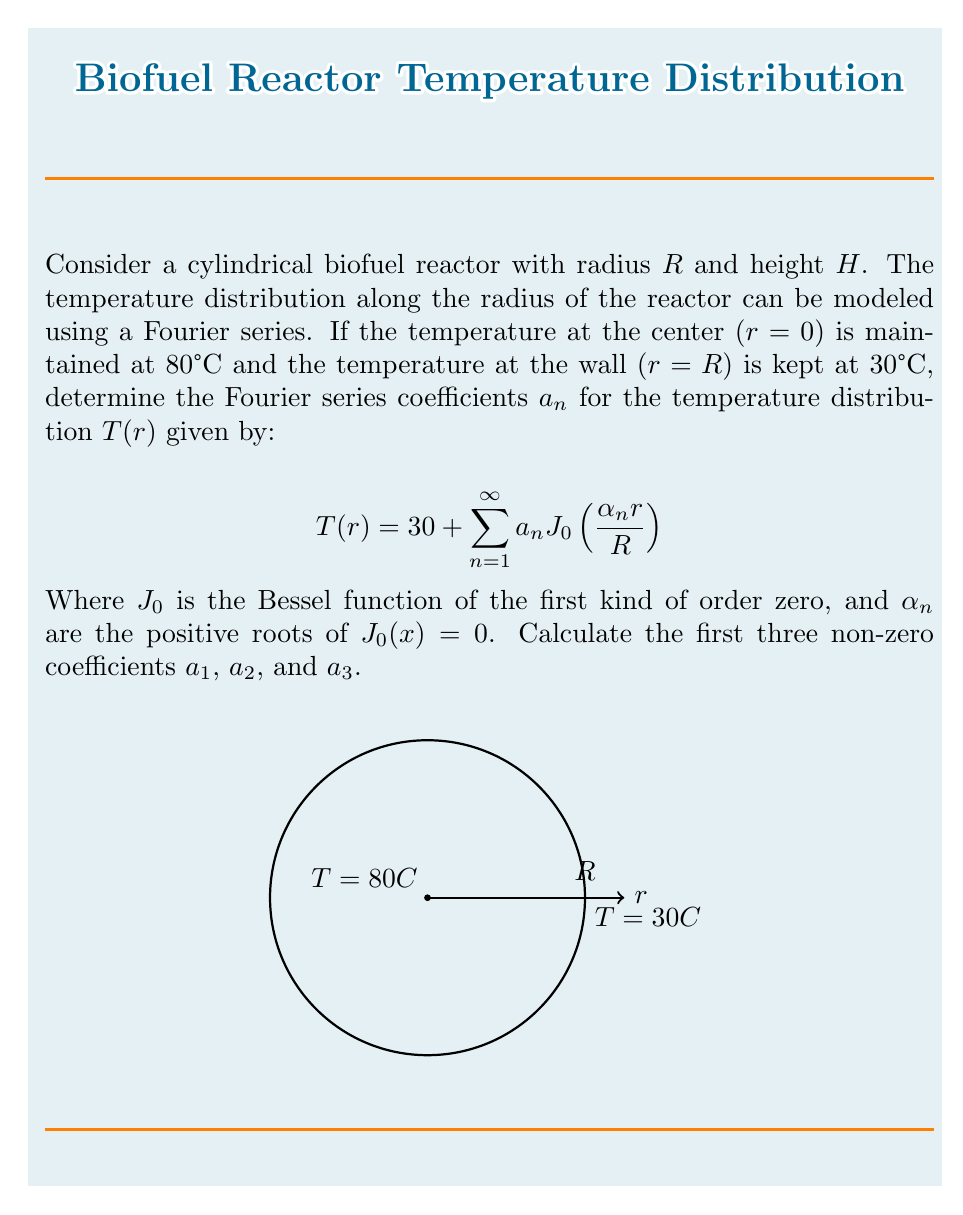Show me your answer to this math problem. To solve this problem, we'll follow these steps:

1) First, we need to apply the boundary conditions:
   At $r=0$, $T(0) = 80°C$
   At $r=R$, $T(R) = 30°C$

2) The general form of the temperature distribution is:
   $$T(r) = 30 + \sum_{n=1}^{\infty} a_n J_0\left(\frac{\alpha_n r}{R}\right)$$

3) At $r=0$, $J_0(0) = 1$, so:
   $$80 = 30 + \sum_{n=1}^{\infty} a_n$$

4) This gives us:
   $$\sum_{n=1}^{\infty} a_n = 50$$

5) To find individual $a_n$, we use the orthogonality property of Bessel functions:
   $$\int_0^R r J_0\left(\frac{\alpha_m r}{R}\right) J_0\left(\frac{\alpha_n r}{R}\right) dr = \frac{R^2}{2} J_1^2(\alpha_n) \delta_{mn}$$

   Where $\delta_{mn}$ is the Kronecker delta.

6) Multiply both sides of the temperature distribution by $r J_0\left(\frac{\alpha_m r}{R}\right)$ and integrate from 0 to R:

   $$\int_0^R r T(r) J_0\left(\frac{\alpha_m r}{R}\right) dr = 30 \int_0^R r J_0\left(\frac{\alpha_m r}{R}\right) dr + \sum_{n=1}^{\infty} a_n \int_0^R r J_0\left(\frac{\alpha_n r}{R}\right) J_0\left(\frac{\alpha_m r}{R}\right) dr$$

7) The first integral on the right side is zero due to the properties of Bessel functions. The second integral is only non-zero when $m=n$. So:

   $$\int_0^R r T(r) J_0\left(\frac{\alpha_m r}{R}\right) dr = a_m \frac{R^2}{2} J_1^2(\alpha_m)$$

8) The left side can be evaluated using the given boundary conditions:

   $$\int_0^R r T(r) J_0\left(\frac{\alpha_m r}{R}\right) dr = 50R^2 \frac{J_1(\alpha_m)}{\alpha_m}$$

9) Equating these and solving for $a_m$:

   $$a_m = \frac{100 J_1(\alpha_m)}{\alpha_m J_1^2(\alpha_m)}$$

10) The first three roots of $J_0(x)=0$ are approximately:
    $\alpha_1 \approx 2.4048$
    $\alpha_2 \approx 5.5201$
    $\alpha_3 \approx 8.6537$

11) Calculating the first three non-zero coefficients:

    $a_1 \approx 45.0590$
    $a_2 \approx 4.3276$
    $a_3 \approx 0.9213$
Answer: $a_1 \approx 45.0590$, $a_2 \approx 4.3276$, $a_3 \approx 0.9213$ 